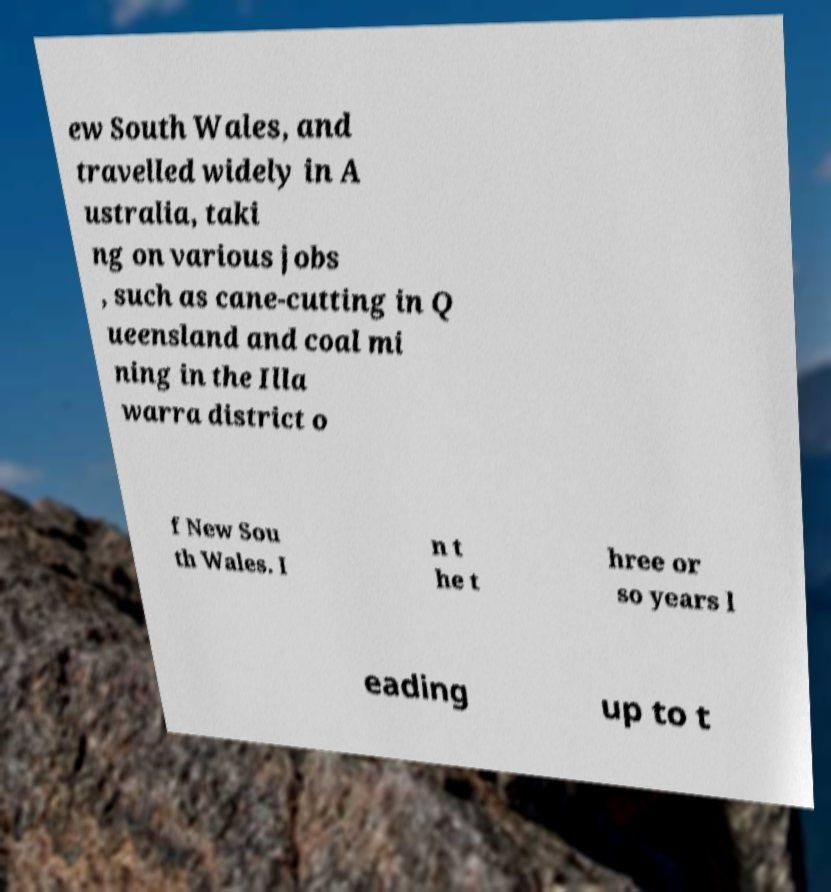For documentation purposes, I need the text within this image transcribed. Could you provide that? ew South Wales, and travelled widely in A ustralia, taki ng on various jobs , such as cane-cutting in Q ueensland and coal mi ning in the Illa warra district o f New Sou th Wales. I n t he t hree or so years l eading up to t 